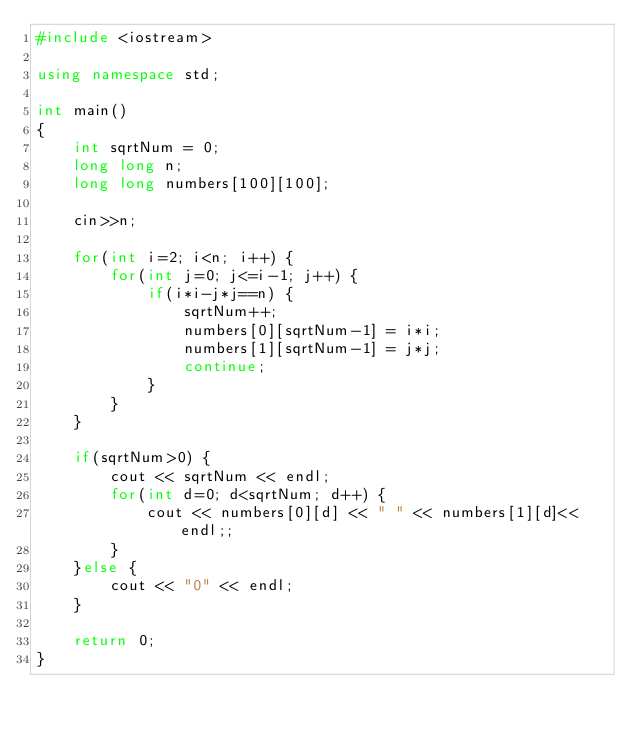<code> <loc_0><loc_0><loc_500><loc_500><_C++_>#include <iostream>

using namespace std;

int main()
{
    int sqrtNum = 0;
    long long n;
    long long numbers[100][100];

    cin>>n;

    for(int i=2; i<n; i++) {
        for(int j=0; j<=i-1; j++) {
            if(i*i-j*j==n) {
                sqrtNum++;
                numbers[0][sqrtNum-1] = i*i;
                numbers[1][sqrtNum-1] = j*j;
                continue;
            }
        }
    }

    if(sqrtNum>0) {
        cout << sqrtNum << endl;
        for(int d=0; d<sqrtNum; d++) {
            cout << numbers[0][d] << " " << numbers[1][d]<<endl;;
        }
    }else {
        cout << "0" << endl;
    }

    return 0;
}</code> 